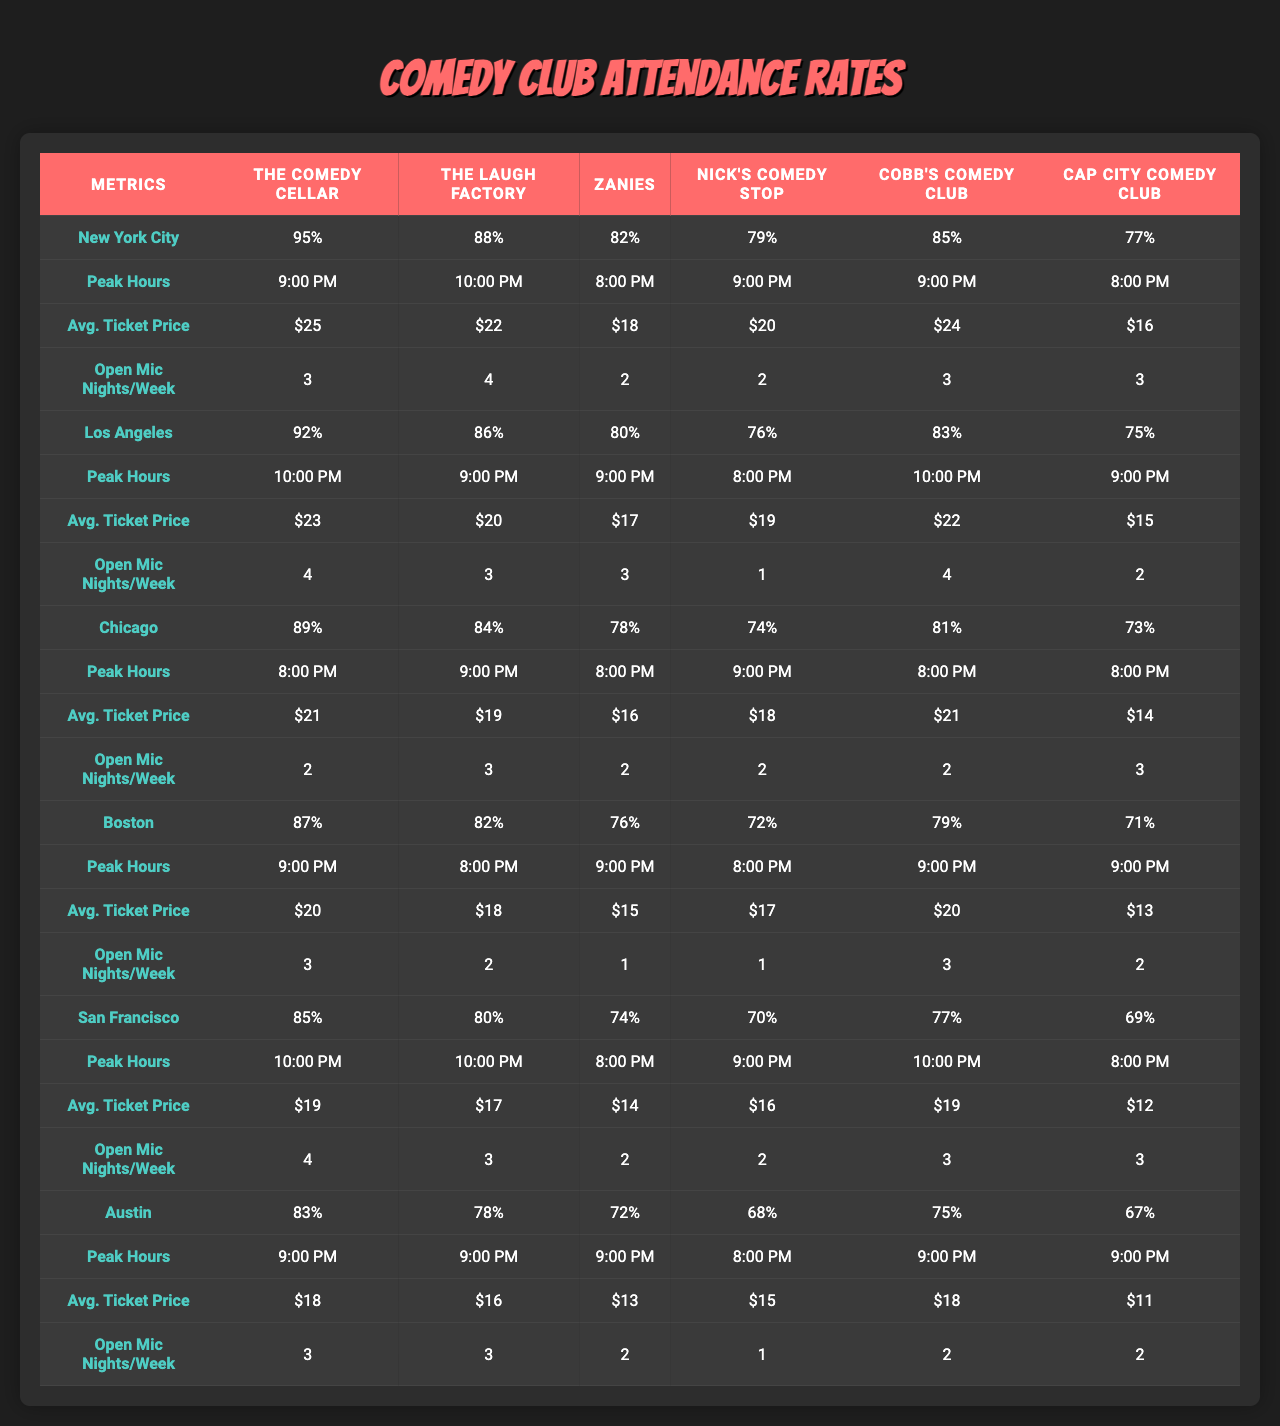What city has the highest attendance rate for The Comedy Cellar? The attendance rates for The Comedy Cellar across cities are: NYC - 95%, LA - 92%, Chicago - 89%, Boston - 87%, San Francisco - 85%, Austin - 83%. The highest is in New York City at 95%.
Answer: New York City What is the average ticket price for The Laugh Factory in Los Angeles? The average ticket price for The Laugh Factory in Los Angeles is $20, which is listed in the corresponding row for LA under the 'Avg. Ticket Price' section.
Answer: $20 Which city has the peak hours of 10:00 PM? Looking at the peak hours for each city and club, Los Angeles has a peak hour of 10:00 PM for The Laugh Factory and San Francisco has a peak hour of 10:00 PM for Cobb's Comedy Club.
Answer: Los Angeles and San Francisco What is the average attendance rate for open mic nights across all cities? To find the average attendance rate, we first sum the attendance rates for each city: 95 + 92 + 89 + 87 + 85 + 83 = 531. Then we divide by the number of cities (6): 531 / 6 = 88.5%.
Answer: 88.5% Which comedy club has the lowest attendance rate overall? The lowest attendance rates for clubs in each city are: 77% for The Comedy Cellar, 75% for The Laugh Factory, 73% for Zanies, 71% for Nick's Comedy Stop, 69% for Cobb's Comedy Club, and 67% for Cap City Comedy Club. The overall lowest is Cap City Comedy Club at 67%.
Answer: Cap City Comedy Club What is the difference in the average ticket price between The Comedy Cellar in New York City and Cobb's Comedy Club in San Francisco? The average ticket price for The Comedy Cellar in NYC is $25 and for Cobb's Comedy Club in San Francisco it is $19. The difference is calculated as $25 - $19 = $6.
Answer: $6 Does Chicago have a higher number of open mic nights per week than Boston? Chicago has an average of 3 open mic nights per week, while Boston has 2. Since 3 is greater than 2, the statement is true.
Answer: Yes In which city is the ticket price for Cobb's Comedy Club the cheapest, and what is that price? The ticket prices for Cobb's Comedy Club in each city are 24, 22, 21, 20, 19, and 18. The lowest is in Austin at $18.
Answer: Austin, $18 What is the total attendance rate for Zanies across all cities? The attendance rates for Zanies are: 82% (NYC), 80% (LA), 78% (Chicago), 76% (Boston), 74% (San Francisco), and 72% (Austin). The total is 82 + 80 + 78 + 76 + 74 + 72 = 462.
Answer: 462 Which city has the most open mic nights per week on average? The open mic nights per week for each city are: NYC - 3, LA - 4, Chicago - 3, Boston - 3, San Francisco - 4, Austin - 3. Los Angeles and San Francisco both have the highest at 4 nights per week.
Answer: Los Angeles and San Francisco What is the average of the peak hours for The Laugh Factory across the cities? The peak hours for The Laugh Factory are: 10:00 PM (LA), 9:00 PM (NYC), 9:00 PM (Chicago), 8:00 PM (Boston), 10:00 PM (San Francisco), and 9:00 PM (Austin). To average this, we convert them to numbers: 10, 9, 9, 8, 10, 9. Adding gives 55 and dividing by 6 results in 9.17, which rounds to 9:00 PM.
Answer: 9:00 PM 